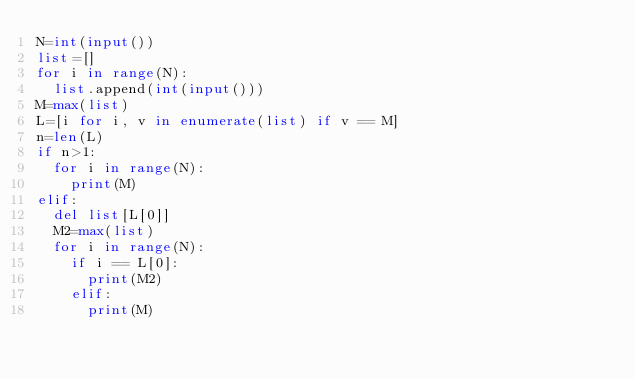Convert code to text. <code><loc_0><loc_0><loc_500><loc_500><_Python_>N=int(input())
list=[]
for i in range(N):
  list.append(int(input()))
M=max(list)
L=[i for i, v in enumerate(list) if v == M]
n=len(L)
if n>1:
  for i in range(N):
    print(M)
elif:
  del list[L[0]]
  M2=max(list)
  for i in range(N):
    if i == L[0]:
      print(M2)
    elif:
      print(M)</code> 